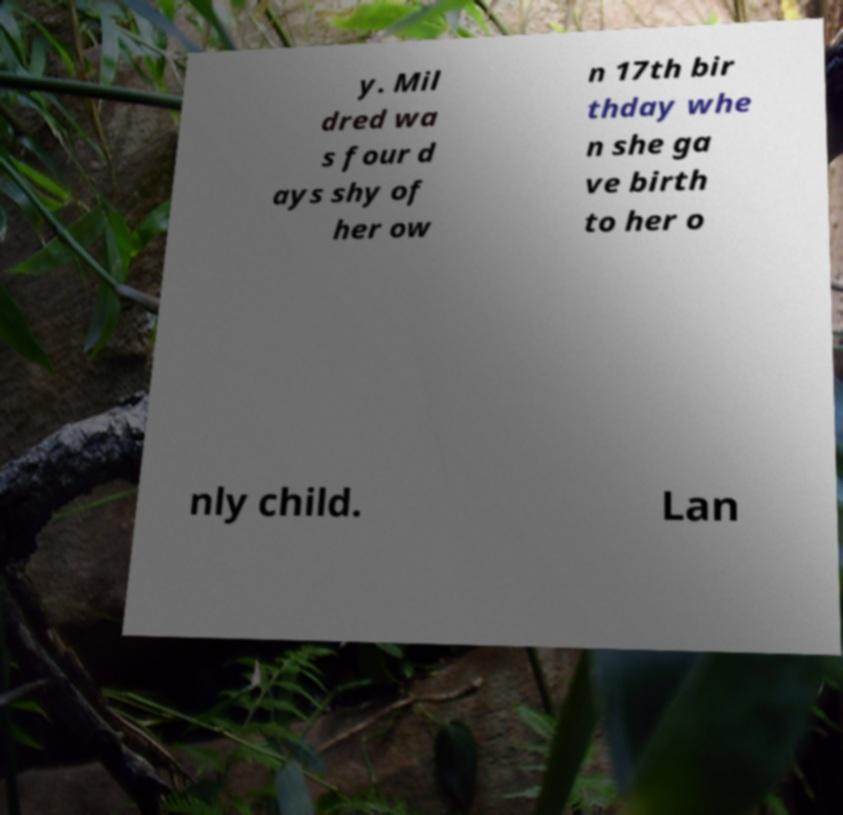Can you accurately transcribe the text from the provided image for me? y. Mil dred wa s four d ays shy of her ow n 17th bir thday whe n she ga ve birth to her o nly child. Lan 